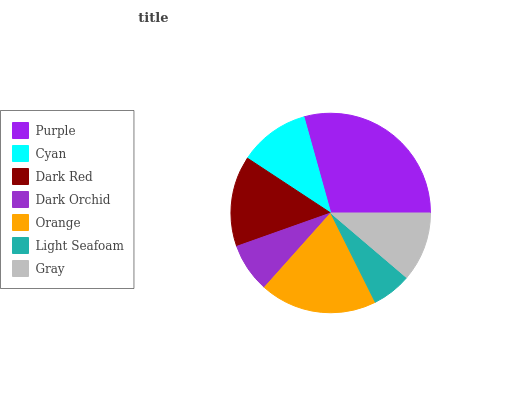Is Light Seafoam the minimum?
Answer yes or no. Yes. Is Purple the maximum?
Answer yes or no. Yes. Is Cyan the minimum?
Answer yes or no. No. Is Cyan the maximum?
Answer yes or no. No. Is Purple greater than Cyan?
Answer yes or no. Yes. Is Cyan less than Purple?
Answer yes or no. Yes. Is Cyan greater than Purple?
Answer yes or no. No. Is Purple less than Cyan?
Answer yes or no. No. Is Cyan the high median?
Answer yes or no. Yes. Is Cyan the low median?
Answer yes or no. Yes. Is Dark Orchid the high median?
Answer yes or no. No. Is Purple the low median?
Answer yes or no. No. 